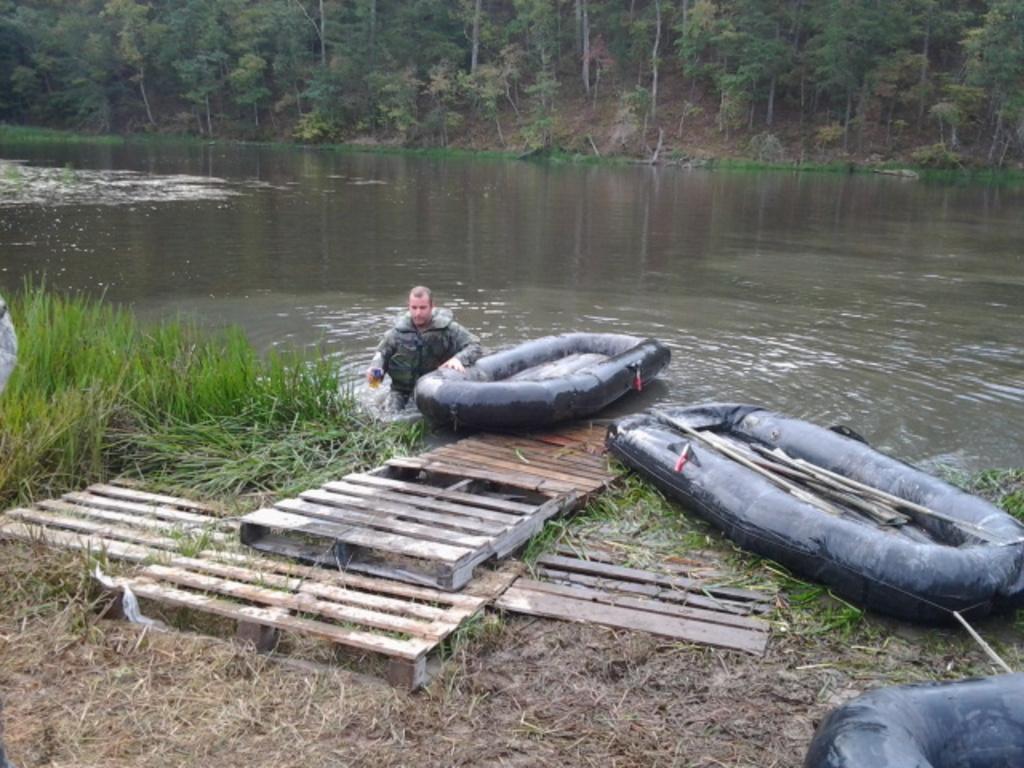Please provide a concise description of this image. In this image I can see few tube boats and I can see few wooden objects. In the background I can see the person in the water and few trees and grass in green color. 